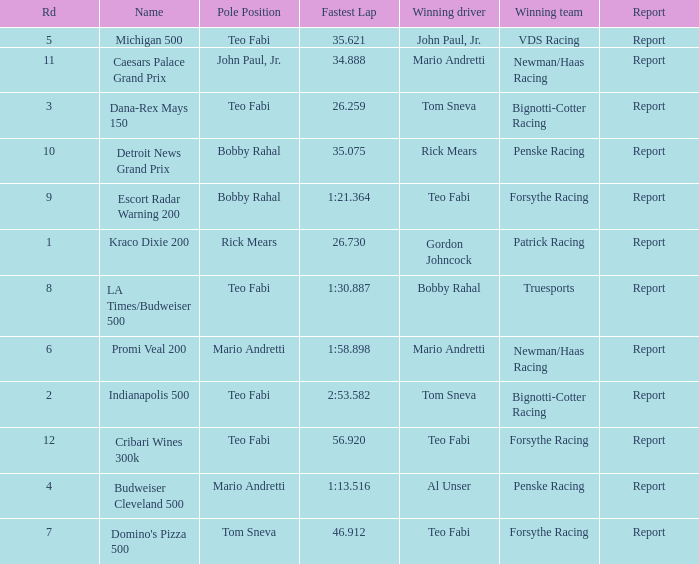Which teams won when Bobby Rahal was their winning driver? Truesports. 